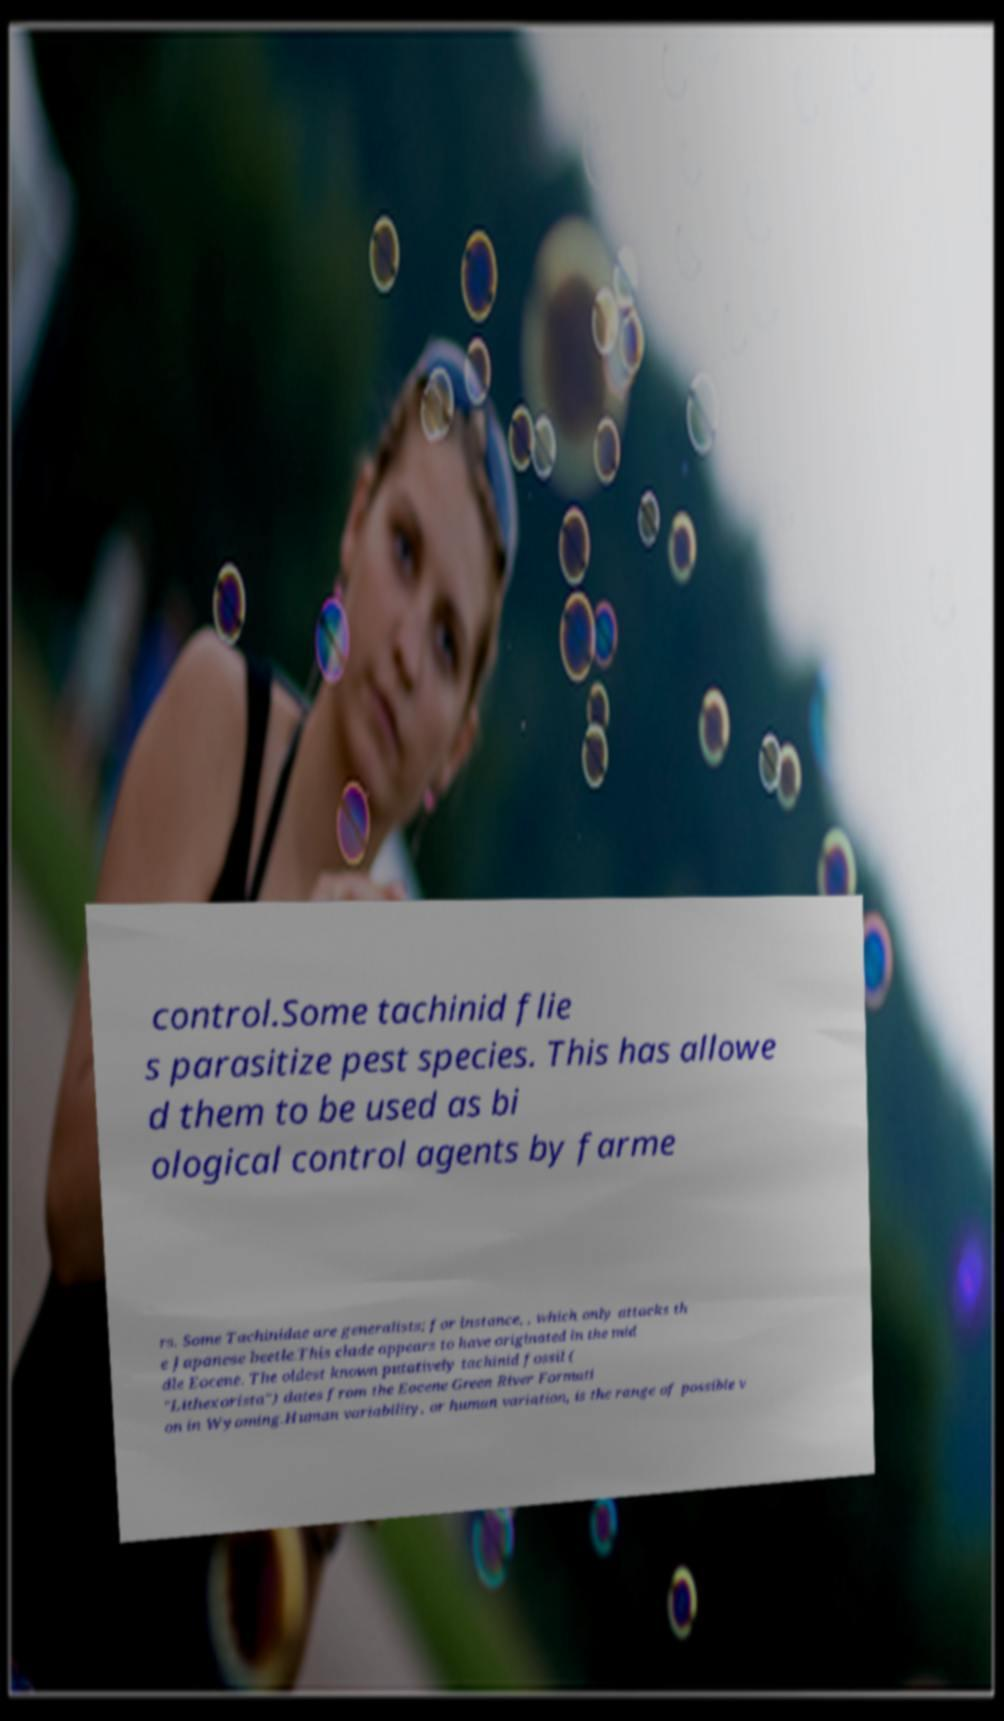What messages or text are displayed in this image? I need them in a readable, typed format. control.Some tachinid flie s parasitize pest species. This has allowe d them to be used as bi ological control agents by farme rs. Some Tachinidae are generalists; for instance, , which only attacks th e Japanese beetle.This clade appears to have originated in the mid dle Eocene. The oldest known putatively tachinid fossil ( "Lithexorista") dates from the Eocene Green River Formati on in Wyoming.Human variability, or human variation, is the range of possible v 